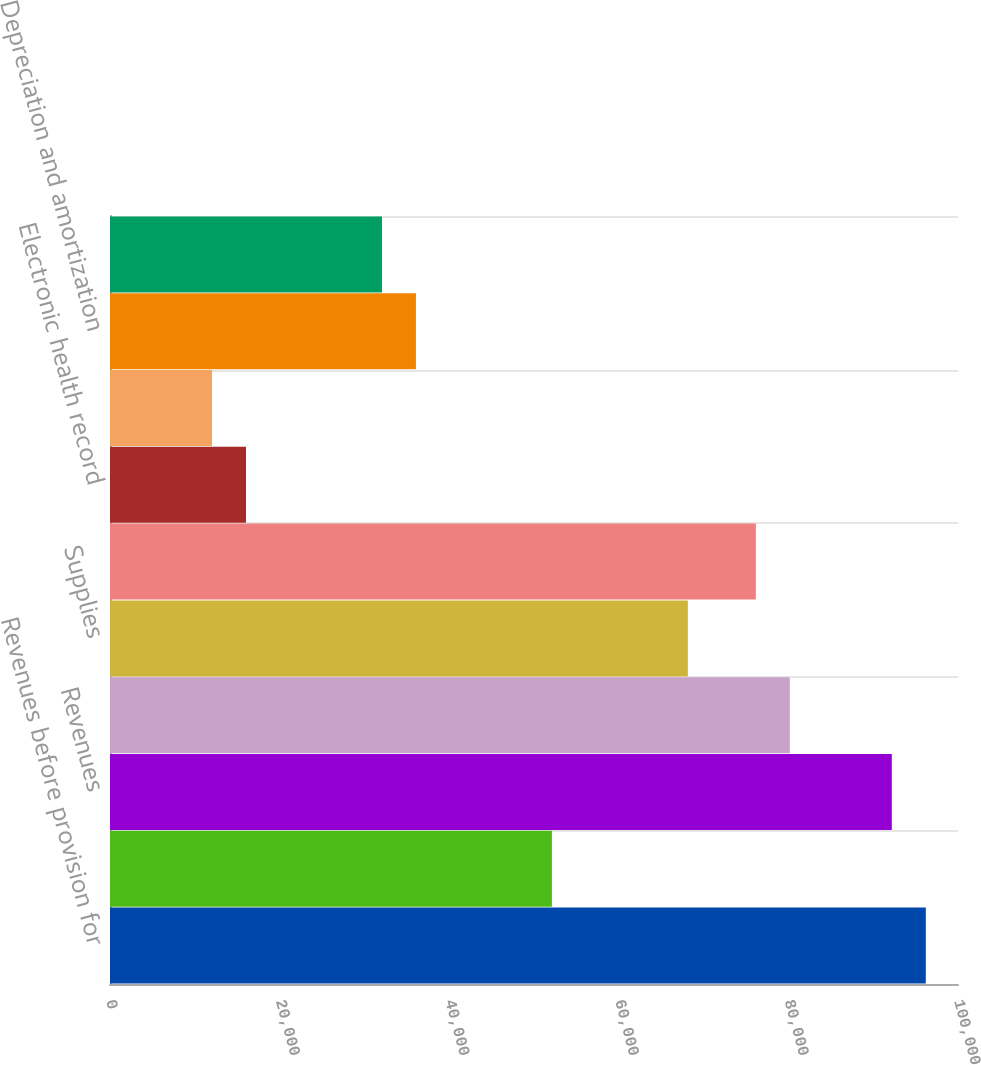Convert chart to OTSL. <chart><loc_0><loc_0><loc_500><loc_500><bar_chart><fcel>Revenues before provision for<fcel>Provision for doubtful<fcel>Revenues<fcel>Salaries and benefits<fcel>Supplies<fcel>Other operating expenses<fcel>Electronic health record<fcel>Equity in earnings of<fcel>Depreciation and amortization<fcel>Interest expense<nl><fcel>96202.9<fcel>52111.8<fcel>92194.6<fcel>80169.8<fcel>68144.9<fcel>76161.5<fcel>16037.3<fcel>12029<fcel>36078.7<fcel>32070.4<nl></chart> 